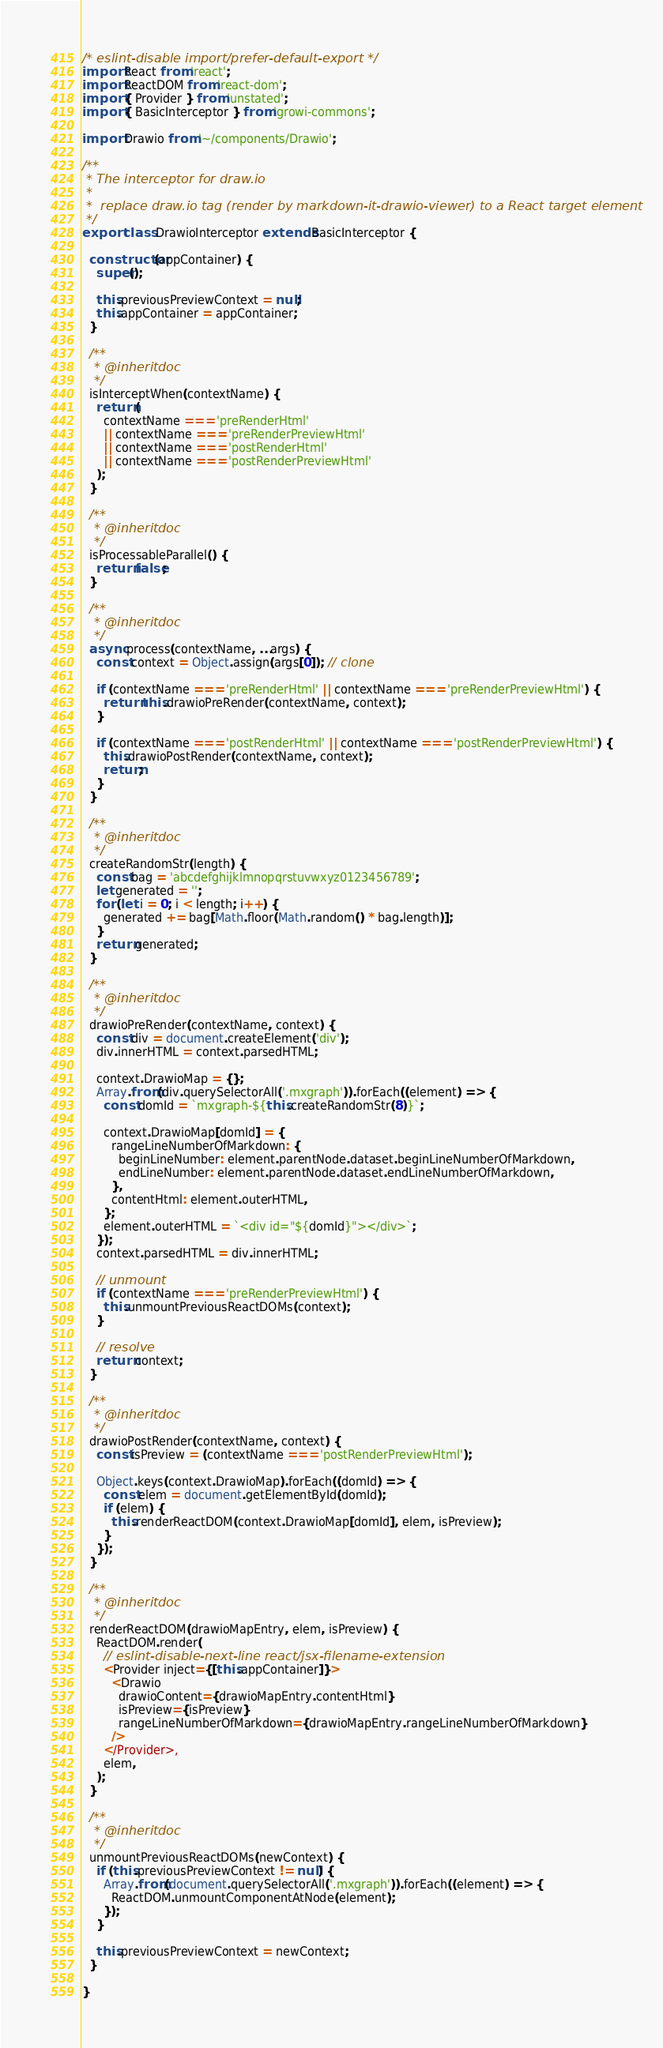Convert code to text. <code><loc_0><loc_0><loc_500><loc_500><_JavaScript_>/* eslint-disable import/prefer-default-export */
import React from 'react';
import ReactDOM from 'react-dom';
import { Provider } from 'unstated';
import { BasicInterceptor } from 'growi-commons';

import Drawio from '~/components/Drawio';

/**
 * The interceptor for draw.io
 *
 *  replace draw.io tag (render by markdown-it-drawio-viewer) to a React target element
 */
export class DrawioInterceptor extends BasicInterceptor {

  constructor(appContainer) {
    super();

    this.previousPreviewContext = null;
    this.appContainer = appContainer;
  }

  /**
   * @inheritdoc
   */
  isInterceptWhen(contextName) {
    return (
      contextName === 'preRenderHtml'
      || contextName === 'preRenderPreviewHtml'
      || contextName === 'postRenderHtml'
      || contextName === 'postRenderPreviewHtml'
    );
  }

  /**
   * @inheritdoc
   */
  isProcessableParallel() {
    return false;
  }

  /**
   * @inheritdoc
   */
  async process(contextName, ...args) {
    const context = Object.assign(args[0]); // clone

    if (contextName === 'preRenderHtml' || contextName === 'preRenderPreviewHtml') {
      return this.drawioPreRender(contextName, context);
    }

    if (contextName === 'postRenderHtml' || contextName === 'postRenderPreviewHtml') {
      this.drawioPostRender(contextName, context);
      return;
    }
  }

  /**
   * @inheritdoc
   */
  createRandomStr(length) {
    const bag = 'abcdefghijklmnopqrstuvwxyz0123456789';
    let generated = '';
    for (let i = 0; i < length; i++) {
      generated += bag[Math.floor(Math.random() * bag.length)];
    }
    return generated;
  }

  /**
   * @inheritdoc
   */
  drawioPreRender(contextName, context) {
    const div = document.createElement('div');
    div.innerHTML = context.parsedHTML;

    context.DrawioMap = {};
    Array.from(div.querySelectorAll('.mxgraph')).forEach((element) => {
      const domId = `mxgraph-${this.createRandomStr(8)}`;

      context.DrawioMap[domId] = {
        rangeLineNumberOfMarkdown: {
          beginLineNumber: element.parentNode.dataset.beginLineNumberOfMarkdown,
          endLineNumber: element.parentNode.dataset.endLineNumberOfMarkdown,
        },
        contentHtml: element.outerHTML,
      };
      element.outerHTML = `<div id="${domId}"></div>`;
    });
    context.parsedHTML = div.innerHTML;

    // unmount
    if (contextName === 'preRenderPreviewHtml') {
      this.unmountPreviousReactDOMs(context);
    }

    // resolve
    return context;
  }

  /**
   * @inheritdoc
   */
  drawioPostRender(contextName, context) {
    const isPreview = (contextName === 'postRenderPreviewHtml');

    Object.keys(context.DrawioMap).forEach((domId) => {
      const elem = document.getElementById(domId);
      if (elem) {
        this.renderReactDOM(context.DrawioMap[domId], elem, isPreview);
      }
    });
  }

  /**
   * @inheritdoc
   */
  renderReactDOM(drawioMapEntry, elem, isPreview) {
    ReactDOM.render(
      // eslint-disable-next-line react/jsx-filename-extension
      <Provider inject={[this.appContainer]}>
        <Drawio
          drawioContent={drawioMapEntry.contentHtml}
          isPreview={isPreview}
          rangeLineNumberOfMarkdown={drawioMapEntry.rangeLineNumberOfMarkdown}
        />
      </Provider>,
      elem,
    );
  }

  /**
   * @inheritdoc
   */
  unmountPreviousReactDOMs(newContext) {
    if (this.previousPreviewContext != null) {
      Array.from(document.querySelectorAll('.mxgraph')).forEach((element) => {
        ReactDOM.unmountComponentAtNode(element);
      });
    }

    this.previousPreviewContext = newContext;
  }

}
</code> 